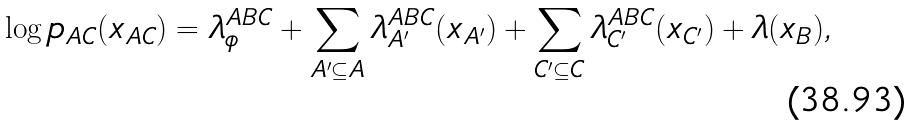Convert formula to latex. <formula><loc_0><loc_0><loc_500><loc_500>\log p _ { A C } ( x _ { A C } ) = \lambda _ { \phi } ^ { A B C } + \sum _ { A ^ { \prime } \subseteq A } \lambda _ { A ^ { \prime } } ^ { A B C } ( x _ { A ^ { \prime } } ) + \sum _ { C ^ { \prime } \subseteq C } \lambda _ { C ^ { \prime } } ^ { A B C } ( x _ { C ^ { \prime } } ) + \lambda ( x _ { B } ) ,</formula> 